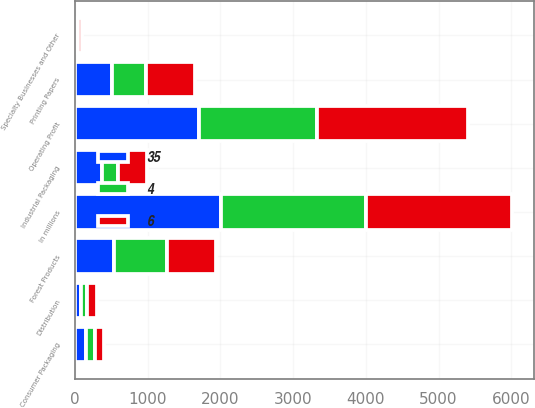Convert chart to OTSL. <chart><loc_0><loc_0><loc_500><loc_500><stacked_bar_chart><ecel><fcel>In millions<fcel>Printing Papers<fcel>Industrial Packaging<fcel>Consumer Packaging<fcel>Distribution<fcel>Forest Products<fcel>Specialty Businesses and Other<fcel>Operating Profit<nl><fcel>6<fcel>2006<fcel>677<fcel>399<fcel>131<fcel>128<fcel>678<fcel>61<fcel>2074<nl><fcel>4<fcel>2005<fcel>473<fcel>219<fcel>121<fcel>84<fcel>721<fcel>4<fcel>1622<nl><fcel>35<fcel>2004<fcel>508<fcel>373<fcel>155<fcel>87<fcel>542<fcel>38<fcel>1703<nl></chart> 